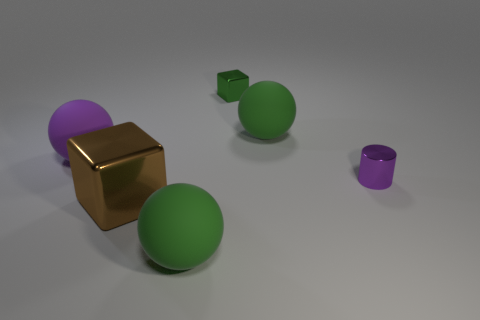Add 1 tiny metal things. How many objects exist? 7 Subtract all cylinders. How many objects are left? 5 Add 3 green objects. How many green objects exist? 6 Subtract 0 brown spheres. How many objects are left? 6 Subtract all tiny rubber cylinders. Subtract all small metallic objects. How many objects are left? 4 Add 2 tiny cylinders. How many tiny cylinders are left? 3 